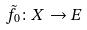Convert formula to latex. <formula><loc_0><loc_0><loc_500><loc_500>\tilde { f } _ { 0 } \colon X \rightarrow E</formula> 